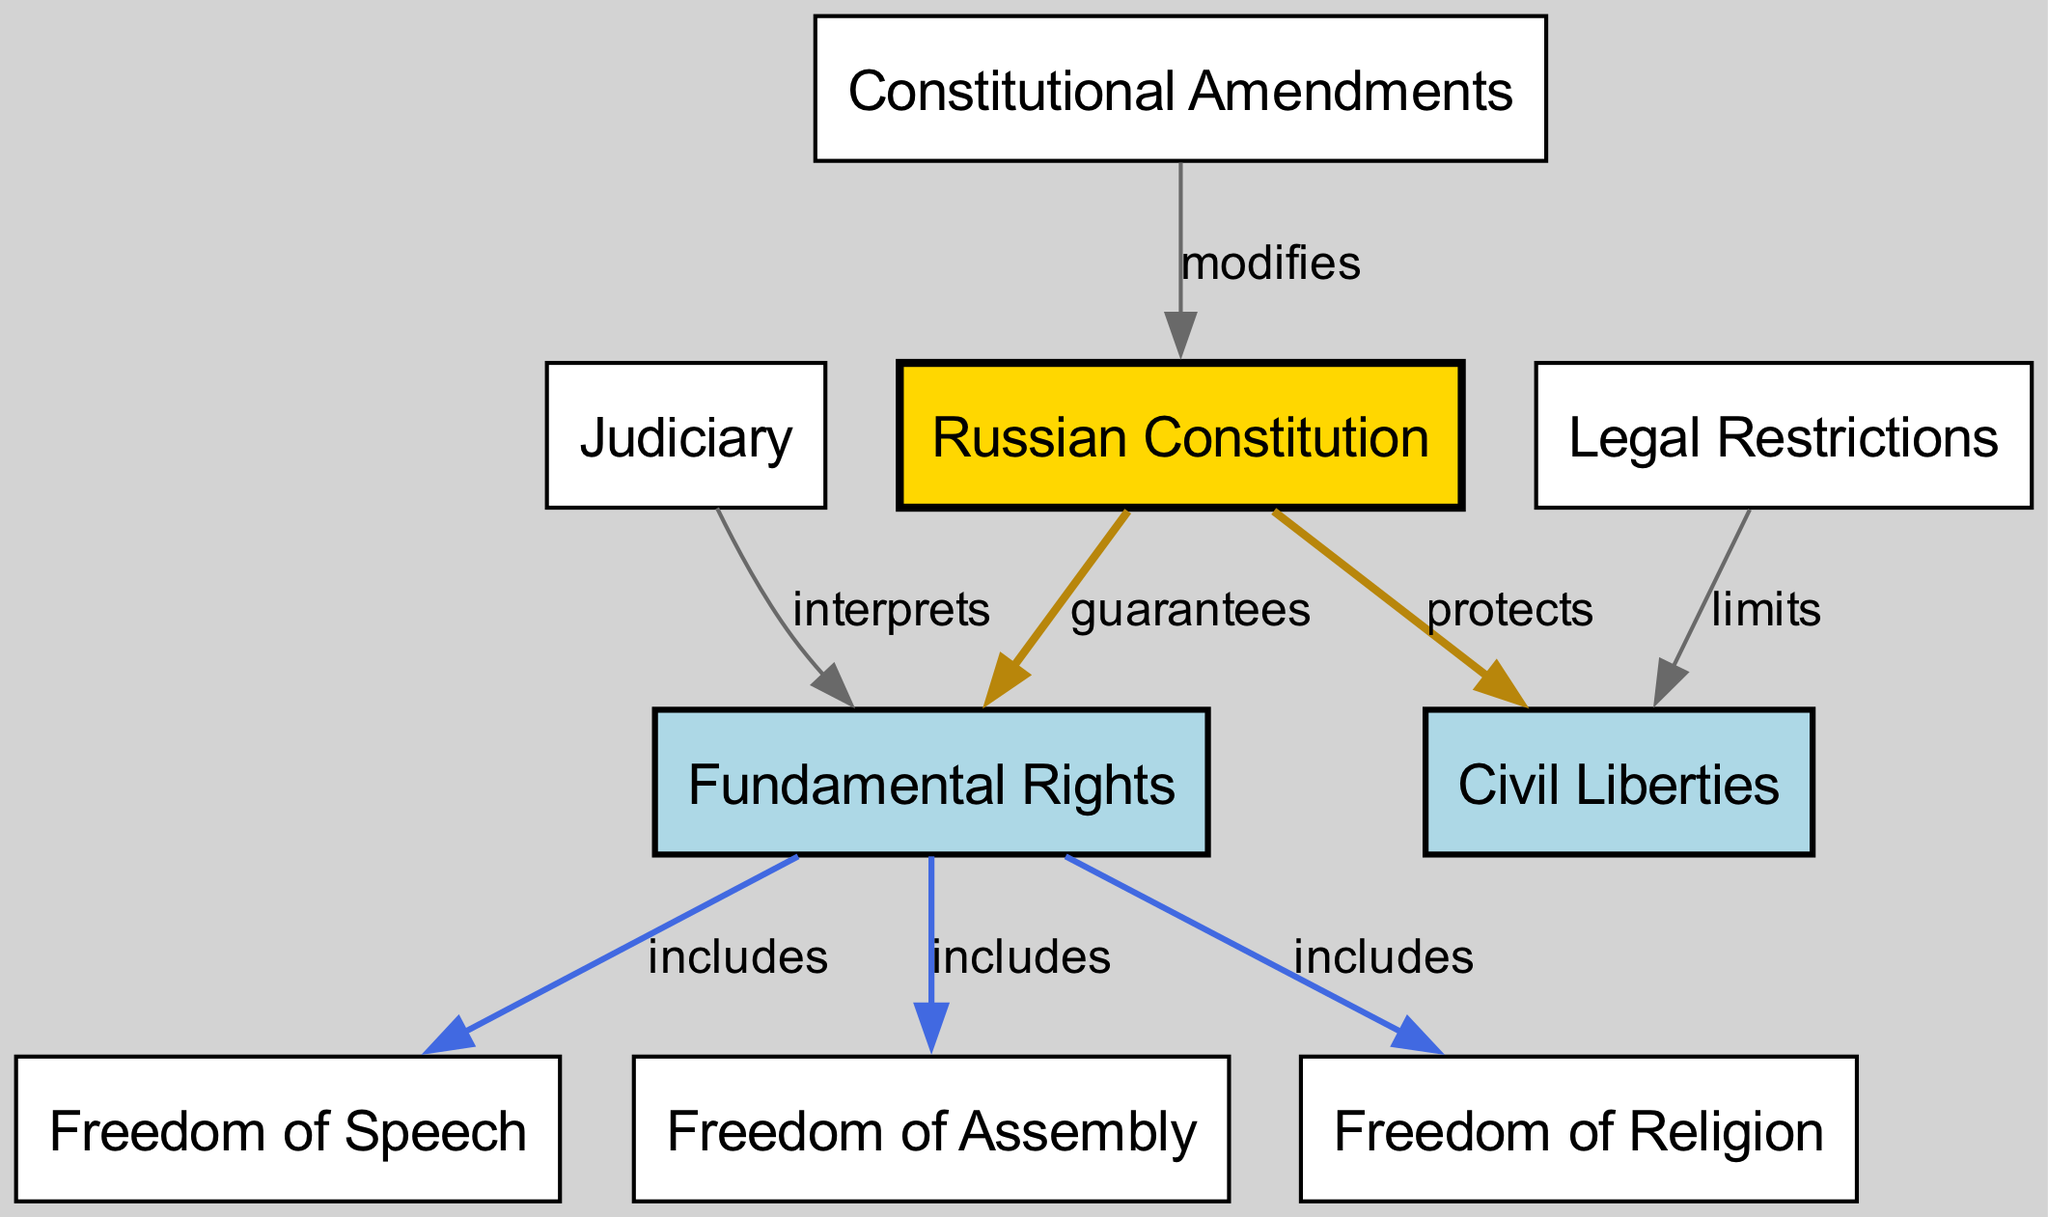What guarantees the fundamental rights in Russia? The diagram shows that the "Russian Constitution" guarantees "Fundamental Rights." This is derived directly from the edge connecting these two nodes labeled "guarantees."
Answer: Russian Constitution What includes fundamental rights in Russia? The edge from "Fundamental Rights" to "Freedom of Speech," "Freedom of Assembly," and "Freedom of Religion" indicates that these liberties are included in the broader category of fundamental rights.
Answer: Freedom of Speech, Freedom of Assembly, Freedom of Religion How does the judiciary relate to fundamental rights? According to the diagram, the "Judiciary" interprets "Fundamental Rights," evidenced by the directed edge connecting them labeled "interprets."
Answer: interprets What limits civil liberties in Russia? The diagram points out that "Legal Restrictions" limit "Civil Liberties," which is indicated by the edge between these two nodes labeled "limits."
Answer: Legal Restrictions How many nodes are in the diagram? To find the total number of nodes, count each unique node listed in the diagram. The nodes are: Russian Constitution, Fundamental Rights, Civil Liberties, Freedom of Speech, Freedom of Assembly, Freedom of Religion, Judiciary, Constitutional Amendments, and Legal Restrictions, totaling 9 nodes.
Answer: 9 What modifies the Russian Constitution? The edge in the diagram connecting "Constitutional Amendments" to "Russian Constitution" indicates that amendments serve to modify the constitution. This is part of the relationship identified by the label "modifies."
Answer: Constitutional Amendments What is the relationship between civil liberties and the constitution? The diagram explicitly states that the "Russian Constitution" protects "Civil Liberties," shown by the direct edge between these two nodes labeled "protects."
Answer: protects What types of freedoms are included under fundamental rights? The included freedoms under fundamental rights as indicated by the edges emanating from "Fundamental Rights" are "Freedom of Speech," "Freedom of Assembly," and "Freedom of Religion." Each is represented as an inclusion of fundamental rights in the diagram.
Answer: Freedom of Speech, Freedom of Assembly, Freedom of Religion What is the role of amendments in the context of the constitution? The diagram highlights that "Constitutional Amendments" have the role of modifying the "Russian Constitution," indicated by the edge labeled "modifies." This signifies that amendments are a means by which the constitution can be altered.
Answer: modifies 